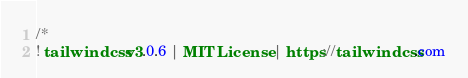<code> <loc_0><loc_0><loc_500><loc_500><_CSS_>/*
! tailwindcss v3.0.6 | MIT License | https://tailwindcss.com</code> 